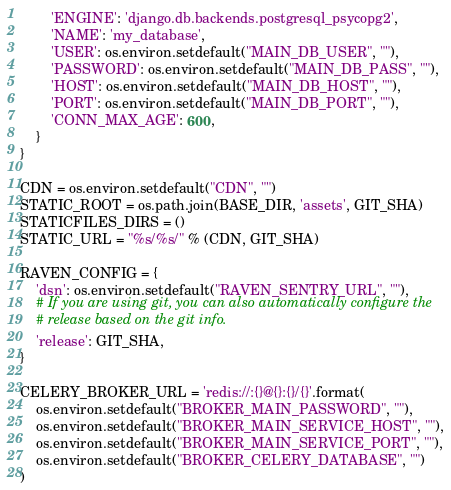<code> <loc_0><loc_0><loc_500><loc_500><_Python_>        'ENGINE': 'django.db.backends.postgresql_psycopg2',
        'NAME': 'my_database',
        'USER': os.environ.setdefault("MAIN_DB_USER", ""),
        'PASSWORD': os.environ.setdefault("MAIN_DB_PASS", ""),
        'HOST': os.environ.setdefault("MAIN_DB_HOST", ""),
        'PORT': os.environ.setdefault("MAIN_DB_PORT", ""),
        'CONN_MAX_AGE': 600,
    }
}

CDN = os.environ.setdefault("CDN", "")
STATIC_ROOT = os.path.join(BASE_DIR, 'assets', GIT_SHA)
STATICFILES_DIRS = ()
STATIC_URL = "%s/%s/" % (CDN, GIT_SHA)

RAVEN_CONFIG = {
    'dsn': os.environ.setdefault("RAVEN_SENTRY_URL", ""),
    # If you are using git, you can also automatically configure the
    # release based on the git info.
    'release': GIT_SHA,
}

CELERY_BROKER_URL = 'redis://:{}@{}:{}/{}'.format(
    os.environ.setdefault("BROKER_MAIN_PASSWORD", ""),
    os.environ.setdefault("BROKER_MAIN_SERVICE_HOST", ""),
    os.environ.setdefault("BROKER_MAIN_SERVICE_PORT", ""),
    os.environ.setdefault("BROKER_CELERY_DATABASE", "")
)
</code> 